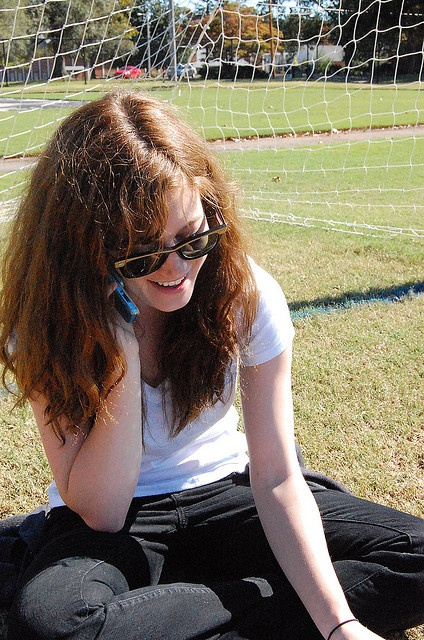Describe the objects in this image and their specific colors. I can see people in olive, black, gray, and maroon tones, cell phone in olive, black, gray, navy, and blue tones, car in olive, salmon, lightpink, and brown tones, and car in olive, gray, darkgray, and lightgray tones in this image. 